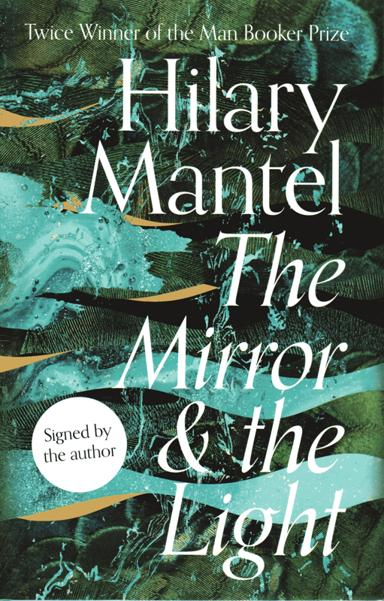What historical period does 'The Mirror and the Light' cover? The Mirror and the Light' by Hilary Mantel is set during the Tudor period, focusing specifically on the final years of Henry VIII's reign. It is the third installment in her Thomas Cromwell trilogy, exploring the complex political and social dynamics of the time. 